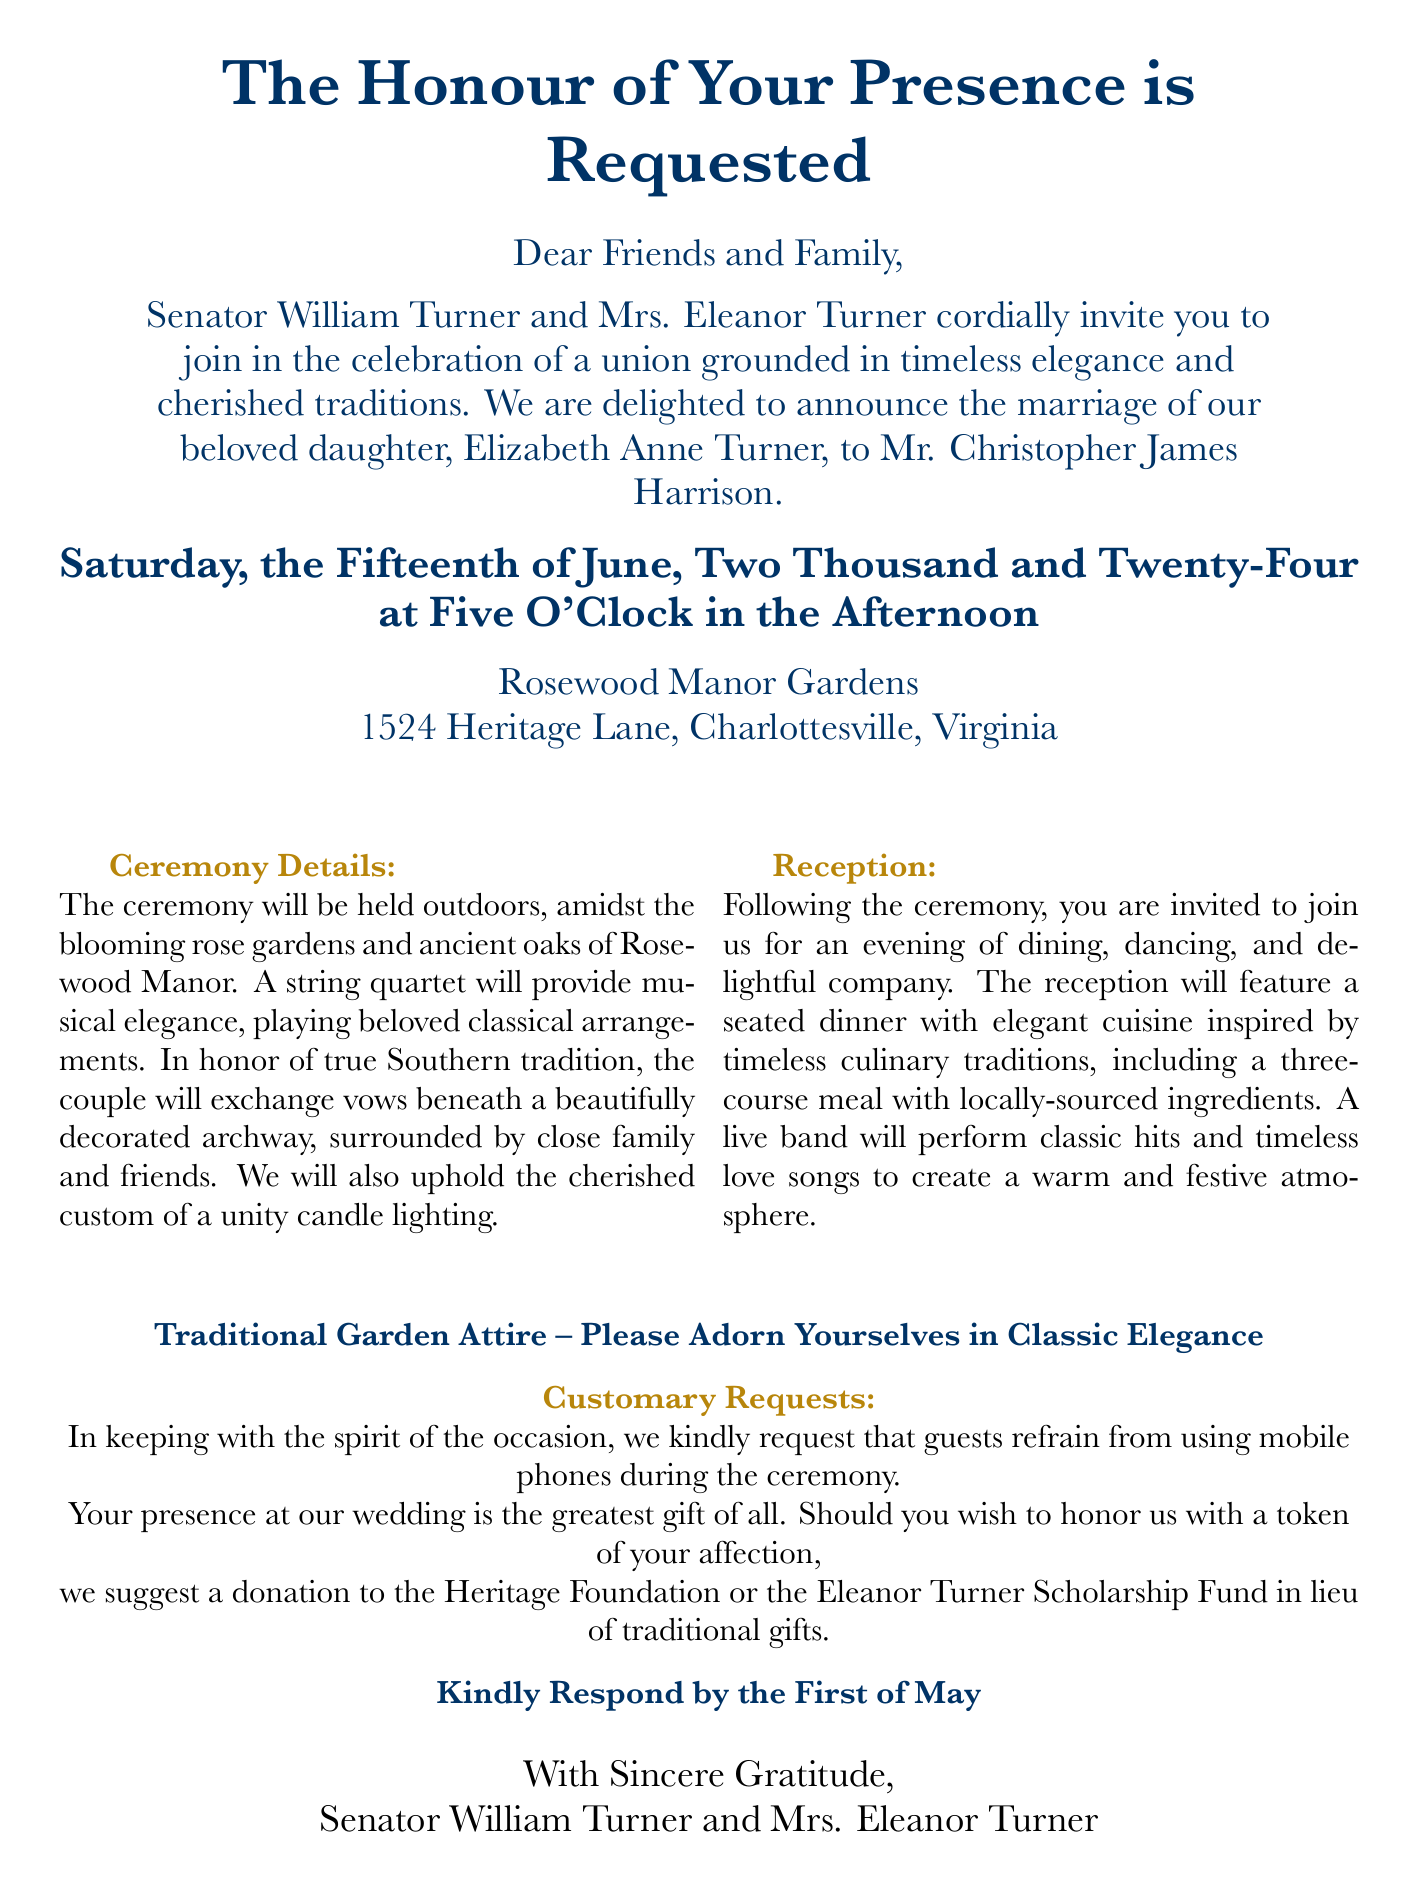What is the date of the wedding? The wedding date is explicitly stated in the invitation as "Saturday, the Fifteenth of June, Two Thousand and Twenty-Four."
Answer: June 15, 2024 Who are the parents of the bride? The document names "Senator William Turner and Mrs. Eleanor Turner" as the parents of the bride.
Answer: Senator William Turner and Mrs. Eleanor Turner What is the location of the ceremony? The invitation specifies the ceremony will be held at "Rosewood Manor Gardens, 1524 Heritage Lane, Charlottesville, Virginia."
Answer: Rosewood Manor Gardens What is requested of guests during the ceremony? The invitation notes a specific request for guests to refrain from using mobile phones during the ceremony.
Answer: Refrain from using mobile phones What type of attire is requested? The document advises guests to wear "Traditional Garden Attire" with an emphasis on "Classic Elegance."
Answer: Traditional Garden Attire How many courses will be served at the reception? The invitation indicates a "three-course meal" will be served during the reception.
Answer: Three courses What type of music will be played during the reception? The reception details mention that a live band will perform "classic hits and timeless love songs."
Answer: Classic hits and timeless love songs By when should guests respond to the invitation? The invitation requests responses by "the First of May."
Answer: May 1 What is suggested instead of traditional gifts? The invitation suggests making a donation to the "Heritage Foundation or the Eleanor Turner Scholarship Fund" in lieu of gifts.
Answer: Heritage Foundation or the Eleanor Turner Scholarship Fund 